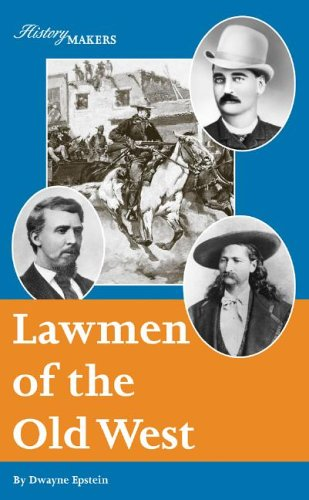Is this a youngster related book? Yes, as a Teen & Young Adult category book, it targets younger audiences with educational yet engaging content that provides insights into American history's lawmen. 